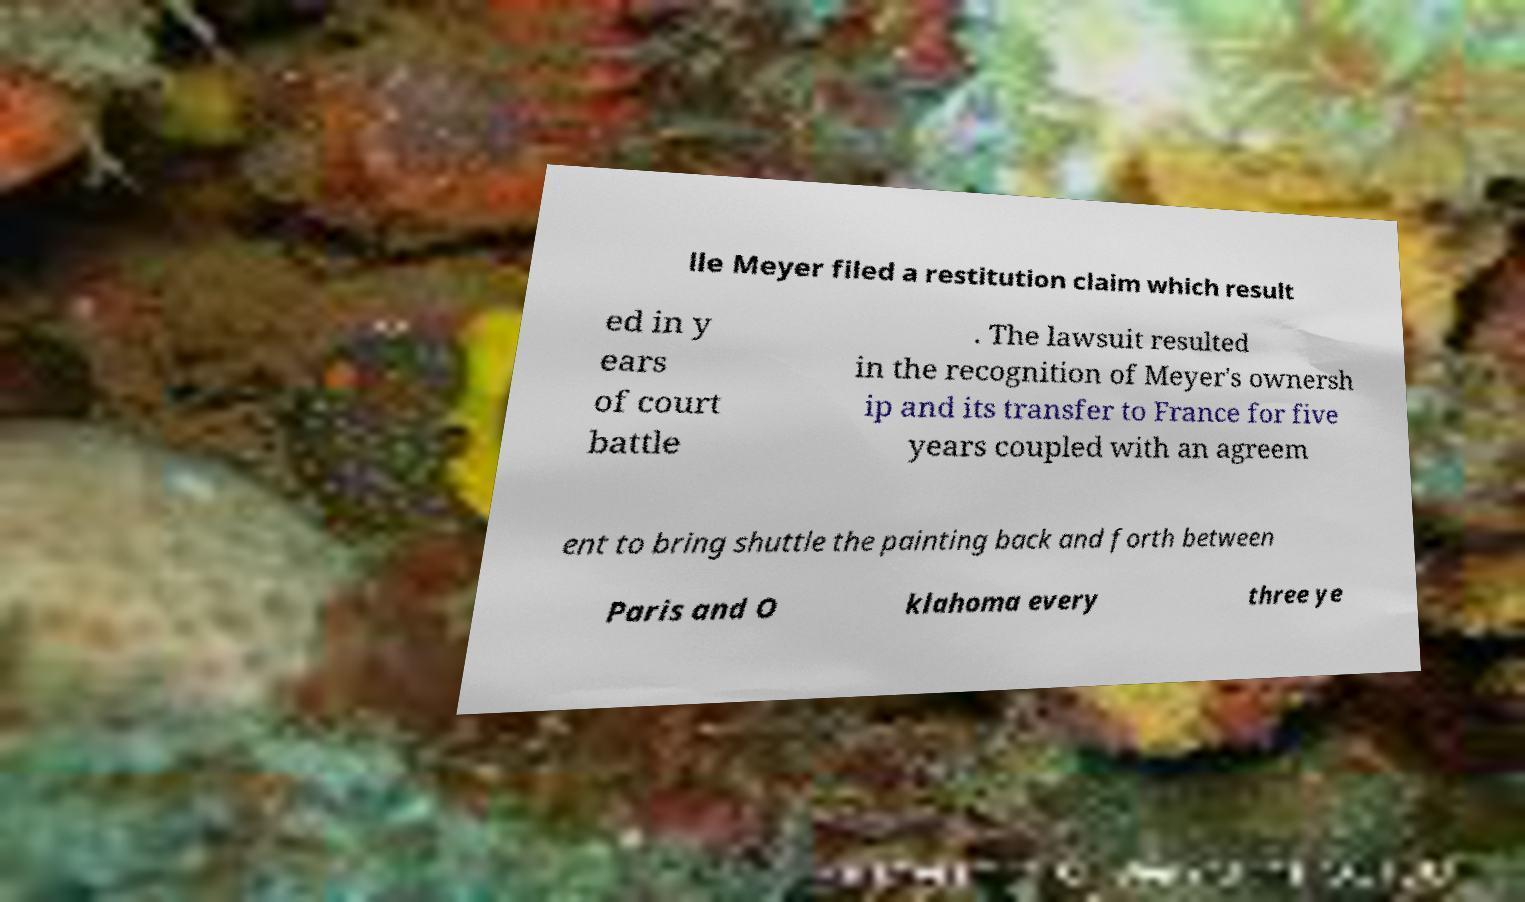Can you accurately transcribe the text from the provided image for me? lle Meyer filed a restitution claim which result ed in y ears of court battle . The lawsuit resulted in the recognition of Meyer's ownersh ip and its transfer to France for five years coupled with an agreem ent to bring shuttle the painting back and forth between Paris and O klahoma every three ye 